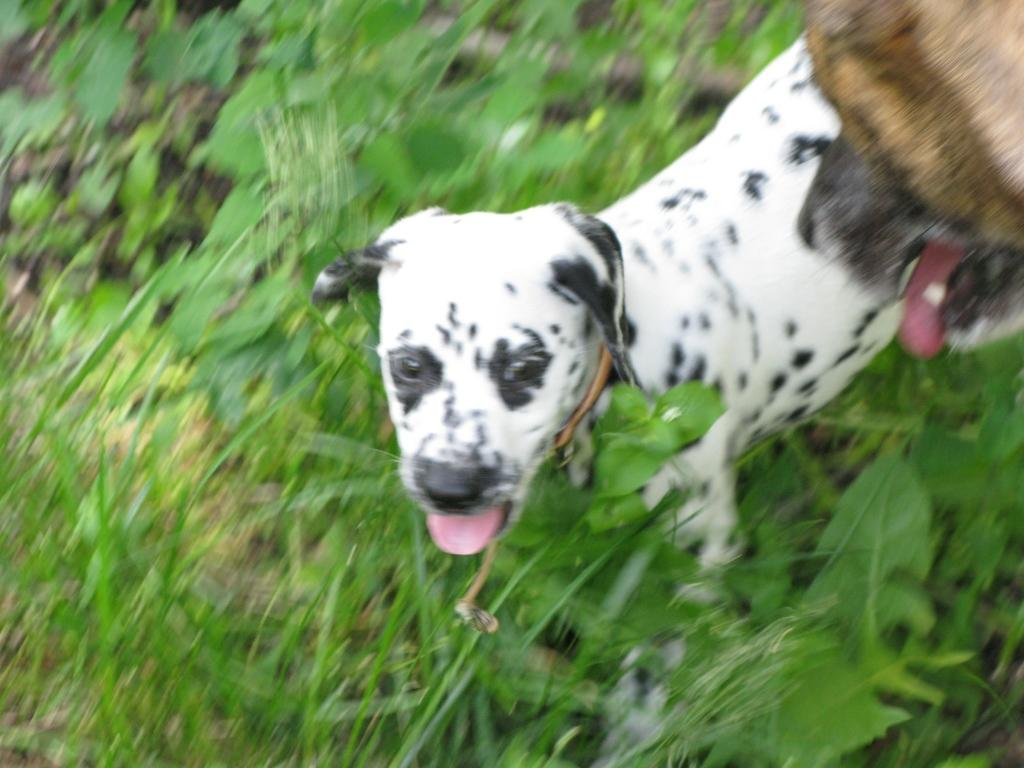What animals are on the right side of the image? There are dogs on the right side of the image. What type of vegetation can be seen in the background of the image? There are plants in the background of the image. What type of joke can be seen in the image? There is no joke present in the image; it features dogs and plants. Can you tell me how many times the dogs sneeze in the image? There is no indication of the dogs sneezing in the image, as it only shows them in a static position. 